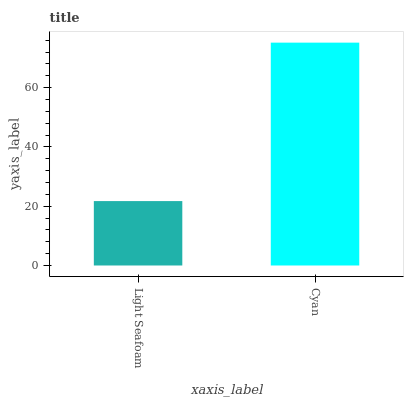Is Light Seafoam the minimum?
Answer yes or no. Yes. Is Cyan the maximum?
Answer yes or no. Yes. Is Cyan the minimum?
Answer yes or no. No. Is Cyan greater than Light Seafoam?
Answer yes or no. Yes. Is Light Seafoam less than Cyan?
Answer yes or no. Yes. Is Light Seafoam greater than Cyan?
Answer yes or no. No. Is Cyan less than Light Seafoam?
Answer yes or no. No. Is Cyan the high median?
Answer yes or no. Yes. Is Light Seafoam the low median?
Answer yes or no. Yes. Is Light Seafoam the high median?
Answer yes or no. No. Is Cyan the low median?
Answer yes or no. No. 